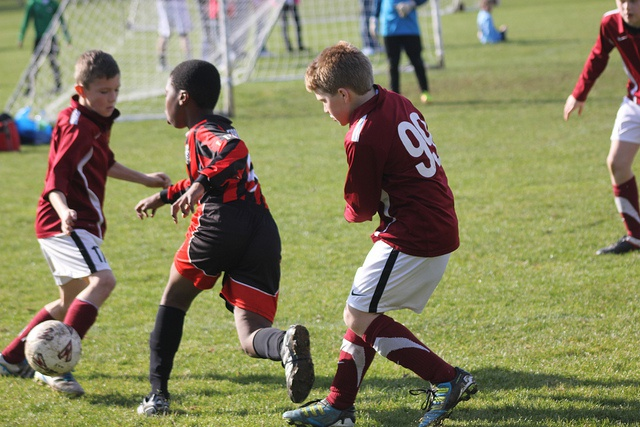Describe the objects in this image and their specific colors. I can see people in olive, black, gray, maroon, and darkgray tones, people in olive, black, maroon, and gray tones, people in olive, black, gray, white, and maroon tones, people in olive, black, gray, maroon, and lavender tones, and people in olive, black, blue, and gray tones in this image. 